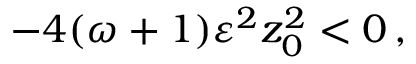Convert formula to latex. <formula><loc_0><loc_0><loc_500><loc_500>- 4 ( \omega + 1 ) \varepsilon ^ { 2 } z _ { 0 } ^ { 2 } < 0 \, ,</formula> 